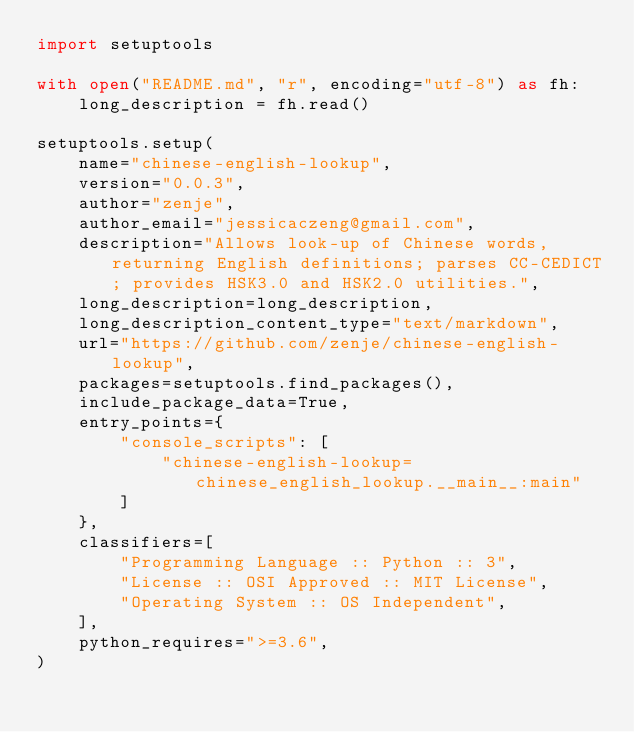<code> <loc_0><loc_0><loc_500><loc_500><_Python_>import setuptools

with open("README.md", "r", encoding="utf-8") as fh:
    long_description = fh.read()

setuptools.setup(
    name="chinese-english-lookup",
    version="0.0.3",
    author="zenje",
    author_email="jessicaczeng@gmail.com",
    description="Allows look-up of Chinese words, returning English definitions; parses CC-CEDICT; provides HSK3.0 and HSK2.0 utilities.",
    long_description=long_description,
    long_description_content_type="text/markdown",
    url="https://github.com/zenje/chinese-english-lookup",
    packages=setuptools.find_packages(),
    include_package_data=True,
    entry_points={
        "console_scripts": [
            "chinese-english-lookup=chinese_english_lookup.__main__:main"
        ]
    },
    classifiers=[
        "Programming Language :: Python :: 3",
        "License :: OSI Approved :: MIT License",
        "Operating System :: OS Independent",
    ],
    python_requires=">=3.6",
)
</code> 